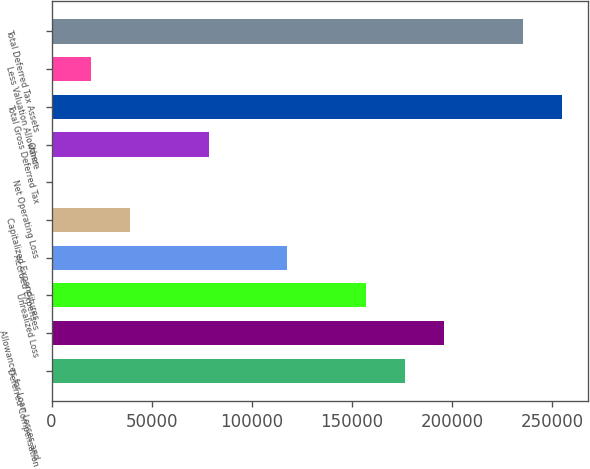Convert chart to OTSL. <chart><loc_0><loc_0><loc_500><loc_500><bar_chart><fcel>Deferred Compensation<fcel>Allowances for Loan Losses and<fcel>Unrealized Loss<fcel>Accrued Expenses<fcel>Capitalized Expenditures<fcel>Net Operating Loss<fcel>Other<fcel>Total Gross Deferred Tax<fcel>Less Valuation Allowance<fcel>Total Deferred Tax Assets<nl><fcel>176597<fcel>196214<fcel>156979<fcel>117744<fcel>39274.8<fcel>40<fcel>78509.6<fcel>255066<fcel>19657.4<fcel>235449<nl></chart> 